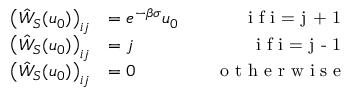Convert formula to latex. <formula><loc_0><loc_0><loc_500><loc_500>\begin{array} { r l r } { \left ( \hat { W } _ { S } ( u _ { 0 } ) \right ) _ { i j } } & { = e ^ { - \beta \sigma } u _ { 0 } \quad } & { i f i = j + 1 } \\ { \left ( \hat { W } _ { S } ( u _ { 0 } ) \right ) _ { i j } } & { = j \quad } & { i f i = j - 1 } \\ { \left ( \hat { W } _ { S } ( u _ { 0 } ) \right ) _ { i j } } & { = 0 \quad } & { o t h e r w i s e } \end{array}</formula> 